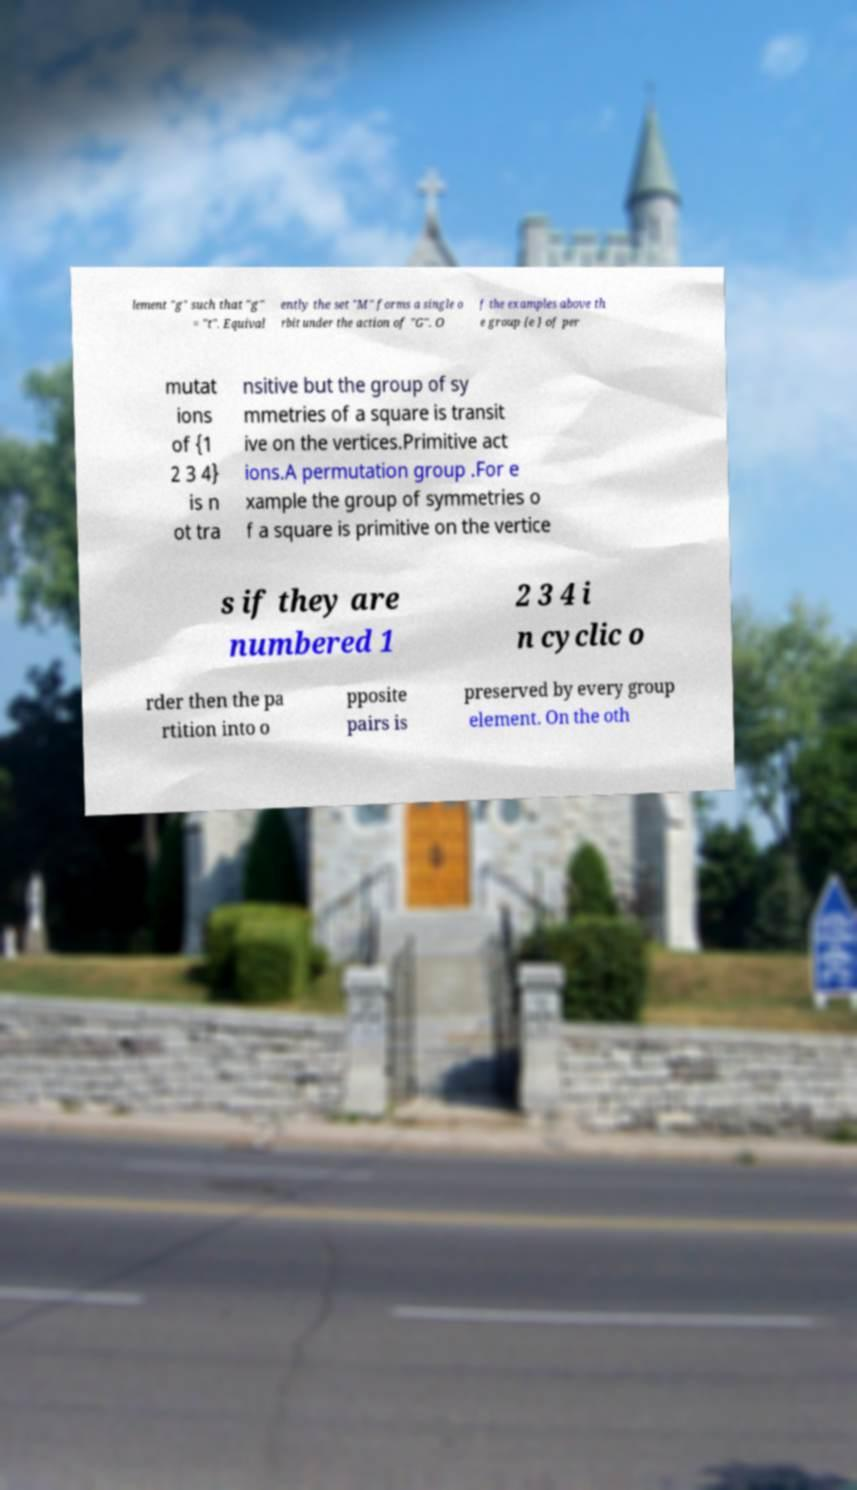Please read and relay the text visible in this image. What does it say? lement "g" such that "g" = "t". Equival ently the set "M" forms a single o rbit under the action of "G". O f the examples above th e group {e } of per mutat ions of {1 2 3 4} is n ot tra nsitive but the group of sy mmetries of a square is transit ive on the vertices.Primitive act ions.A permutation group .For e xample the group of symmetries o f a square is primitive on the vertice s if they are numbered 1 2 3 4 i n cyclic o rder then the pa rtition into o pposite pairs is preserved by every group element. On the oth 